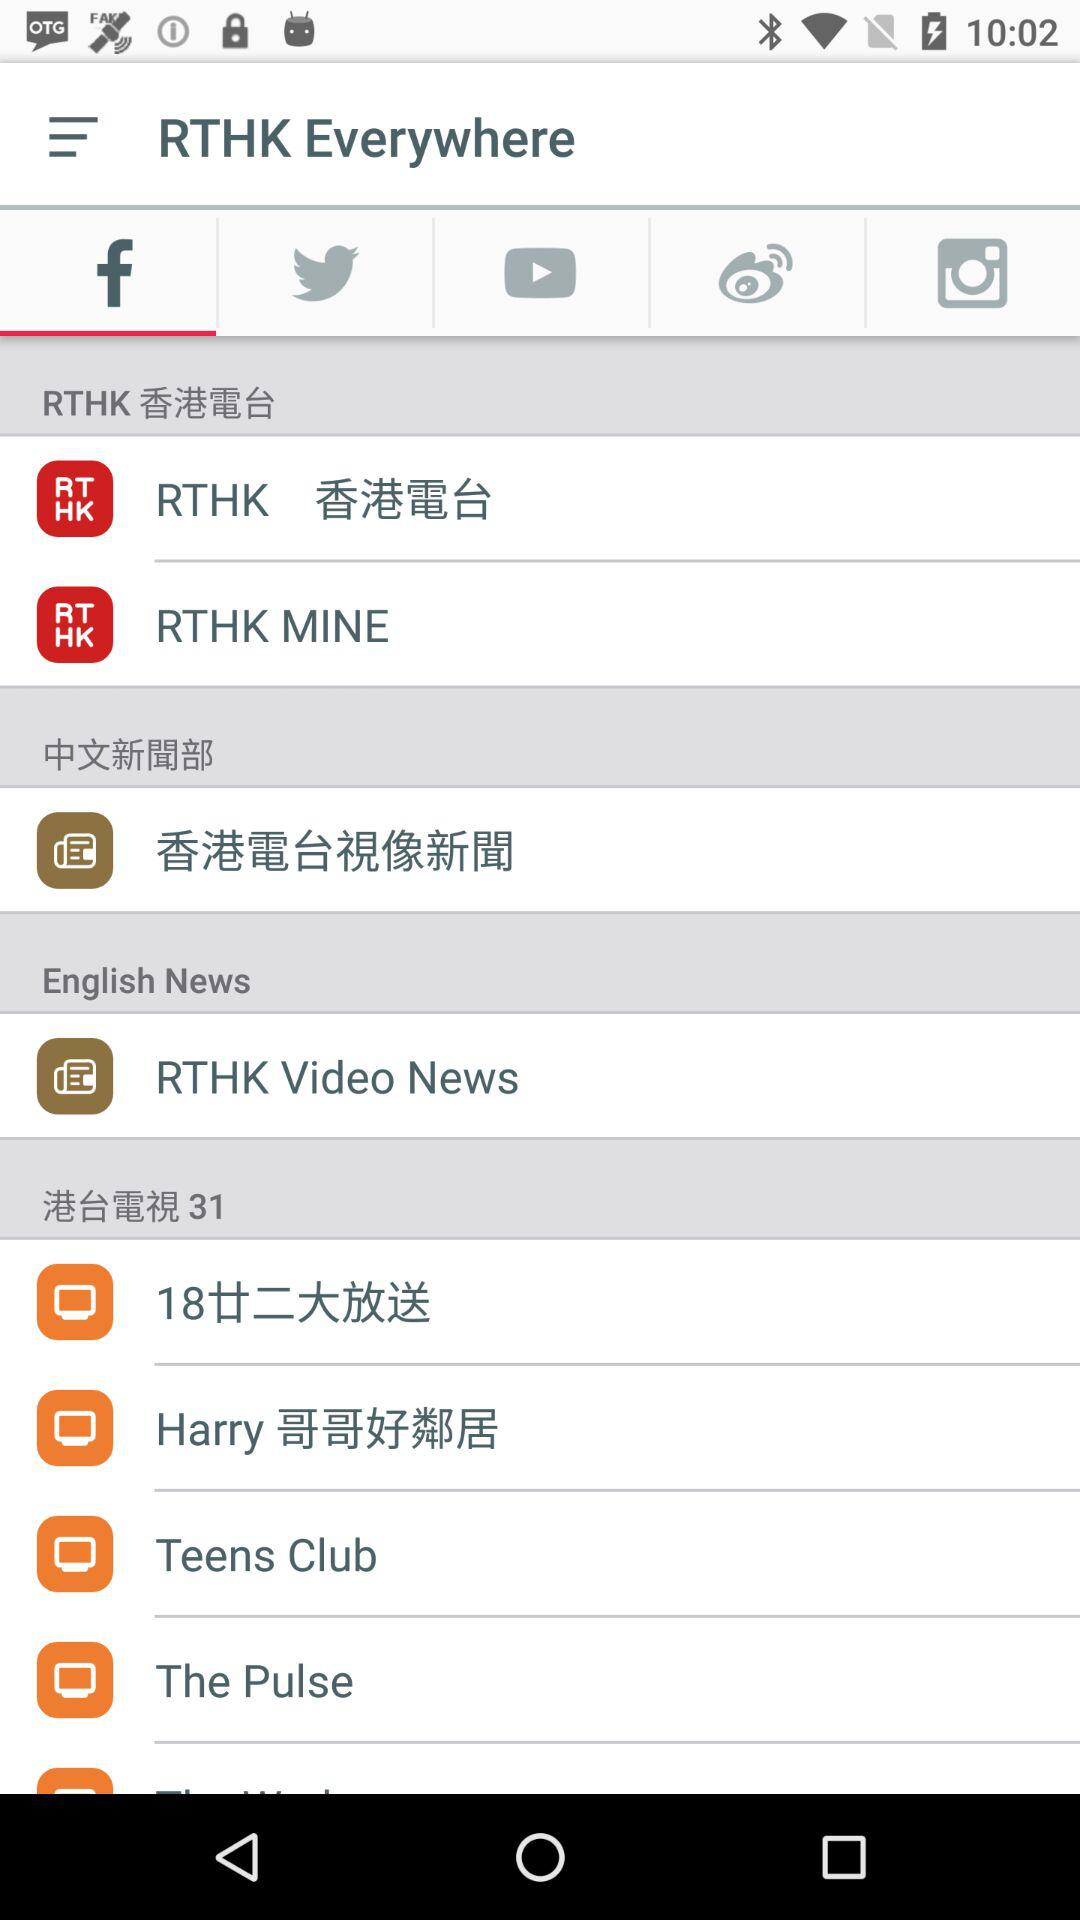What is the app name? The name of the app is "RTHK". 